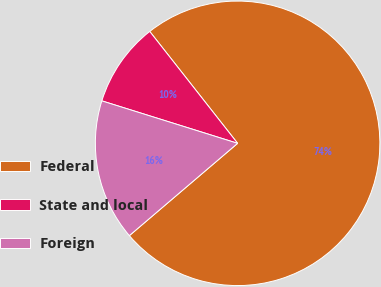Convert chart to OTSL. <chart><loc_0><loc_0><loc_500><loc_500><pie_chart><fcel>Federal<fcel>State and local<fcel>Foreign<nl><fcel>74.36%<fcel>9.58%<fcel>16.06%<nl></chart> 